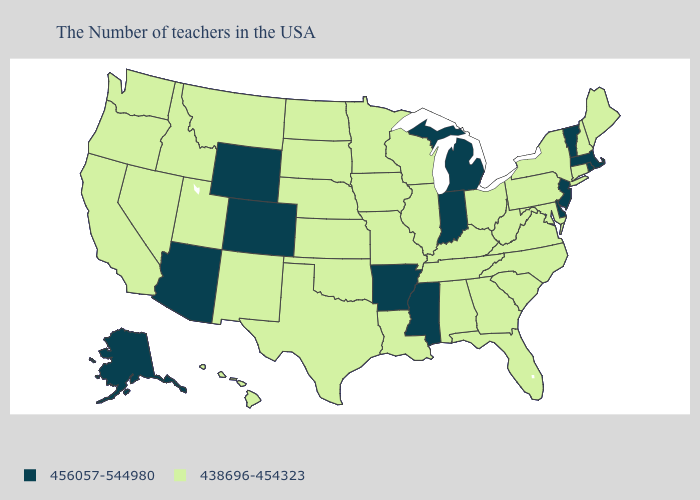Name the states that have a value in the range 438696-454323?
Write a very short answer. Maine, New Hampshire, Connecticut, New York, Maryland, Pennsylvania, Virginia, North Carolina, South Carolina, West Virginia, Ohio, Florida, Georgia, Kentucky, Alabama, Tennessee, Wisconsin, Illinois, Louisiana, Missouri, Minnesota, Iowa, Kansas, Nebraska, Oklahoma, Texas, South Dakota, North Dakota, New Mexico, Utah, Montana, Idaho, Nevada, California, Washington, Oregon, Hawaii. Does Minnesota have the highest value in the USA?
Be succinct. No. Name the states that have a value in the range 438696-454323?
Keep it brief. Maine, New Hampshire, Connecticut, New York, Maryland, Pennsylvania, Virginia, North Carolina, South Carolina, West Virginia, Ohio, Florida, Georgia, Kentucky, Alabama, Tennessee, Wisconsin, Illinois, Louisiana, Missouri, Minnesota, Iowa, Kansas, Nebraska, Oklahoma, Texas, South Dakota, North Dakota, New Mexico, Utah, Montana, Idaho, Nevada, California, Washington, Oregon, Hawaii. What is the value of South Carolina?
Be succinct. 438696-454323. What is the value of Connecticut?
Quick response, please. 438696-454323. Is the legend a continuous bar?
Give a very brief answer. No. What is the highest value in states that border Delaware?
Quick response, please. 456057-544980. Is the legend a continuous bar?
Short answer required. No. Name the states that have a value in the range 456057-544980?
Keep it brief. Massachusetts, Rhode Island, Vermont, New Jersey, Delaware, Michigan, Indiana, Mississippi, Arkansas, Wyoming, Colorado, Arizona, Alaska. Name the states that have a value in the range 456057-544980?
Answer briefly. Massachusetts, Rhode Island, Vermont, New Jersey, Delaware, Michigan, Indiana, Mississippi, Arkansas, Wyoming, Colorado, Arizona, Alaska. What is the lowest value in the West?
Short answer required. 438696-454323. How many symbols are there in the legend?
Be succinct. 2. Among the states that border Arkansas , which have the lowest value?
Keep it brief. Tennessee, Louisiana, Missouri, Oklahoma, Texas. What is the value of North Carolina?
Keep it brief. 438696-454323. 